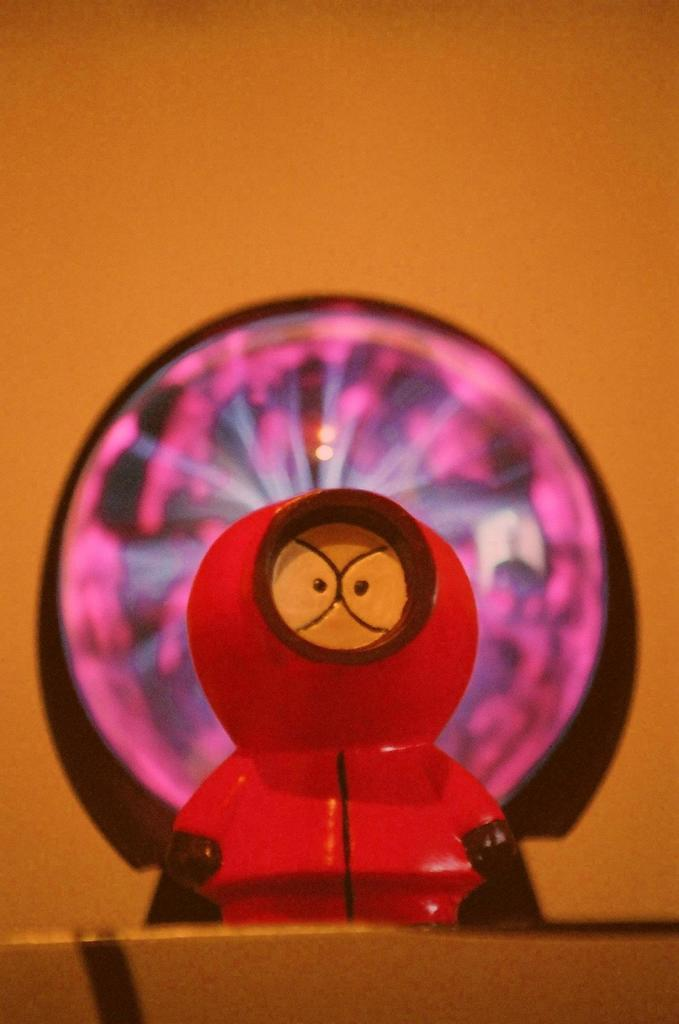What object is the main focus of the image? There is a toy in the image. Can you describe the background of the image? The background of the image is blurred. How many kittens are playing with the toy on the side of the image? There are no kittens present in the image; it only features a toy with a blurred background. 